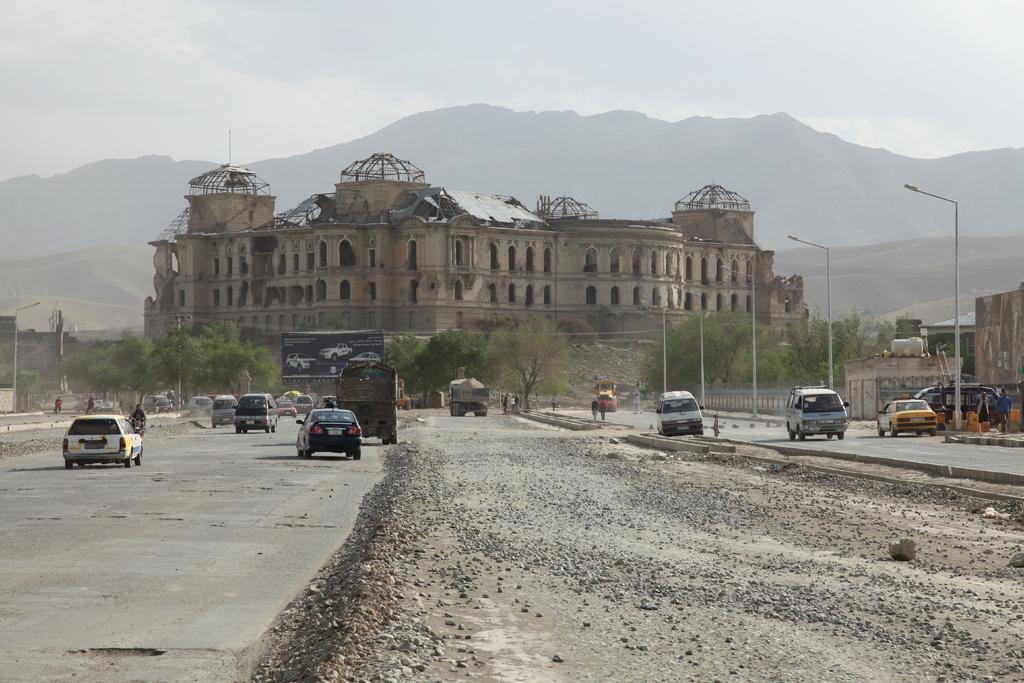Can you describe this image briefly? In the picture we can see two way road in the middle we can see a path some stones and on the road we can see some vehicles and in the background, we can see trees and behind it, we can see a huge building with some broken walls and behind it we can see some hills and the sky. 